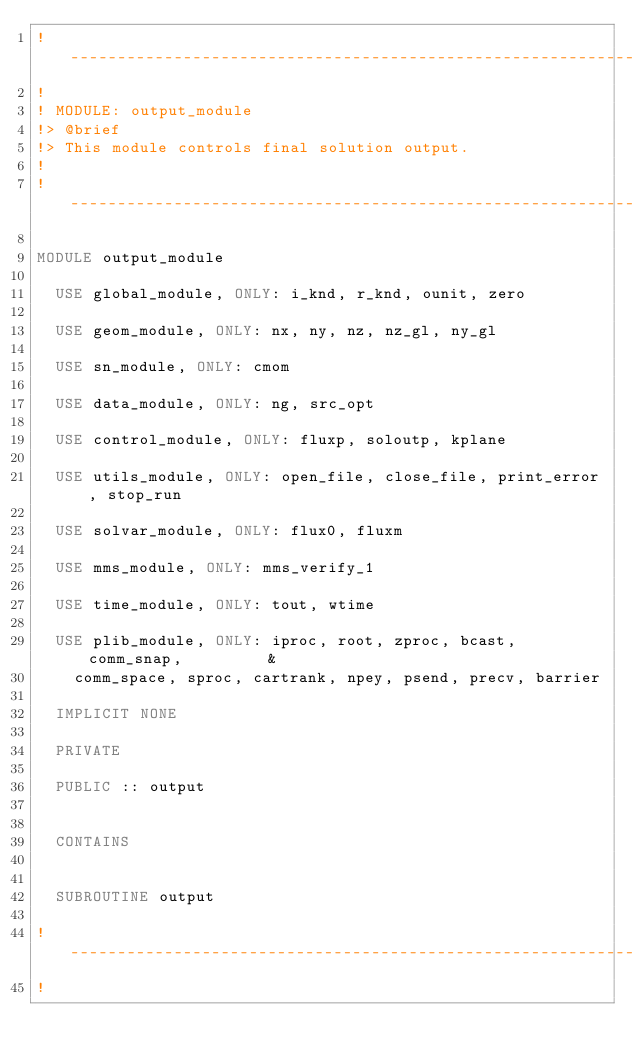<code> <loc_0><loc_0><loc_500><loc_500><_FORTRAN_>!-----------------------------------------------------------------------
!
! MODULE: output_module
!> @brief
!> This module controls final solution output.
!
!-----------------------------------------------------------------------

MODULE output_module

  USE global_module, ONLY: i_knd, r_knd, ounit, zero

  USE geom_module, ONLY: nx, ny, nz, nz_gl, ny_gl

  USE sn_module, ONLY: cmom

  USE data_module, ONLY: ng, src_opt

  USE control_module, ONLY: fluxp, soloutp, kplane

  USE utils_module, ONLY: open_file, close_file, print_error, stop_run

  USE solvar_module, ONLY: flux0, fluxm

  USE mms_module, ONLY: mms_verify_1

  USE time_module, ONLY: tout, wtime

  USE plib_module, ONLY: iproc, root, zproc, bcast, comm_snap,         &
    comm_space, sproc, cartrank, npey, psend, precv, barrier

  IMPLICIT NONE

  PRIVATE

  PUBLIC :: output


  CONTAINS


  SUBROUTINE output

!-----------------------------------------------------------------------
!</code> 